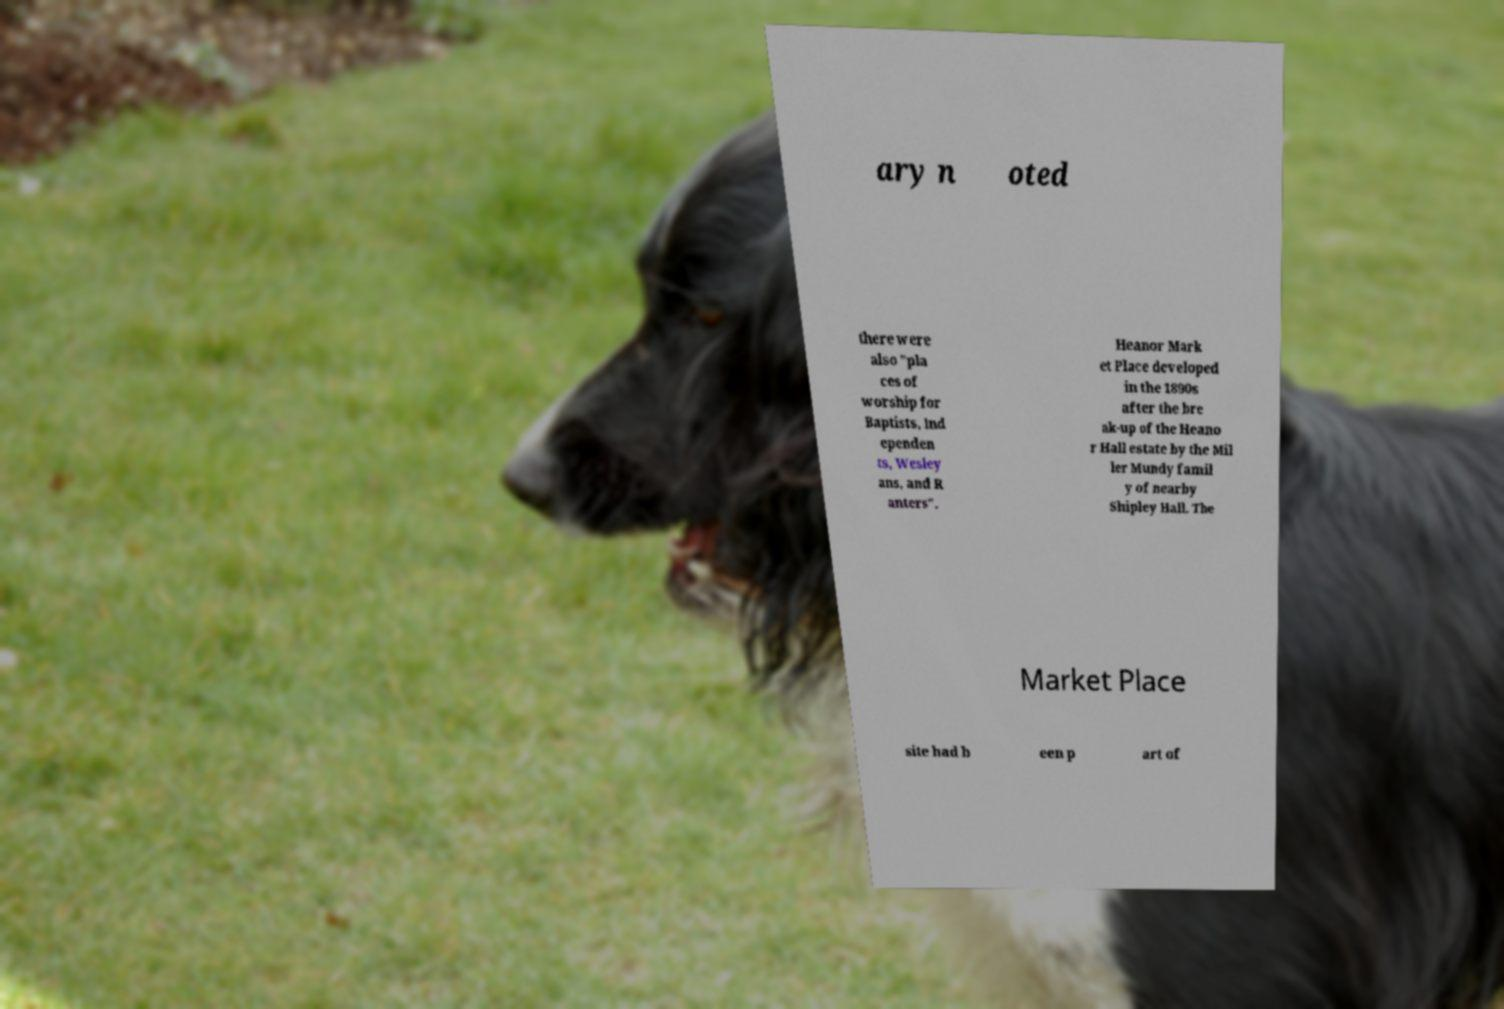Can you read and provide the text displayed in the image?This photo seems to have some interesting text. Can you extract and type it out for me? ary n oted there were also "pla ces of worship for Baptists, Ind ependen ts, Wesley ans, and R anters". Heanor Mark et Place developed in the 1890s after the bre ak-up of the Heano r Hall estate by the Mil ler Mundy famil y of nearby Shipley Hall. The Market Place site had b een p art of 